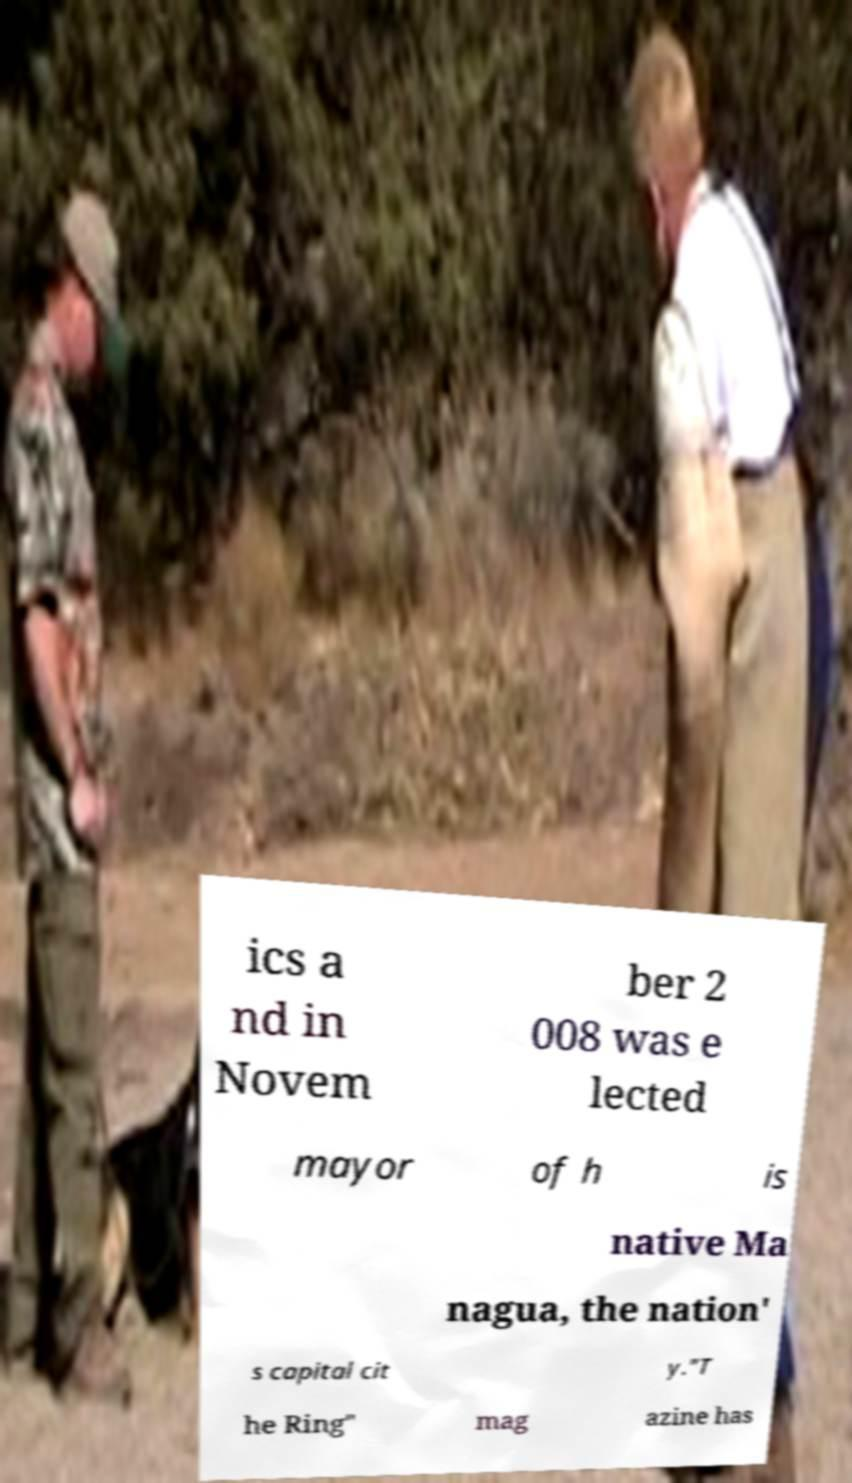For documentation purposes, I need the text within this image transcribed. Could you provide that? ics a nd in Novem ber 2 008 was e lected mayor of h is native Ma nagua, the nation' s capital cit y."T he Ring" mag azine has 